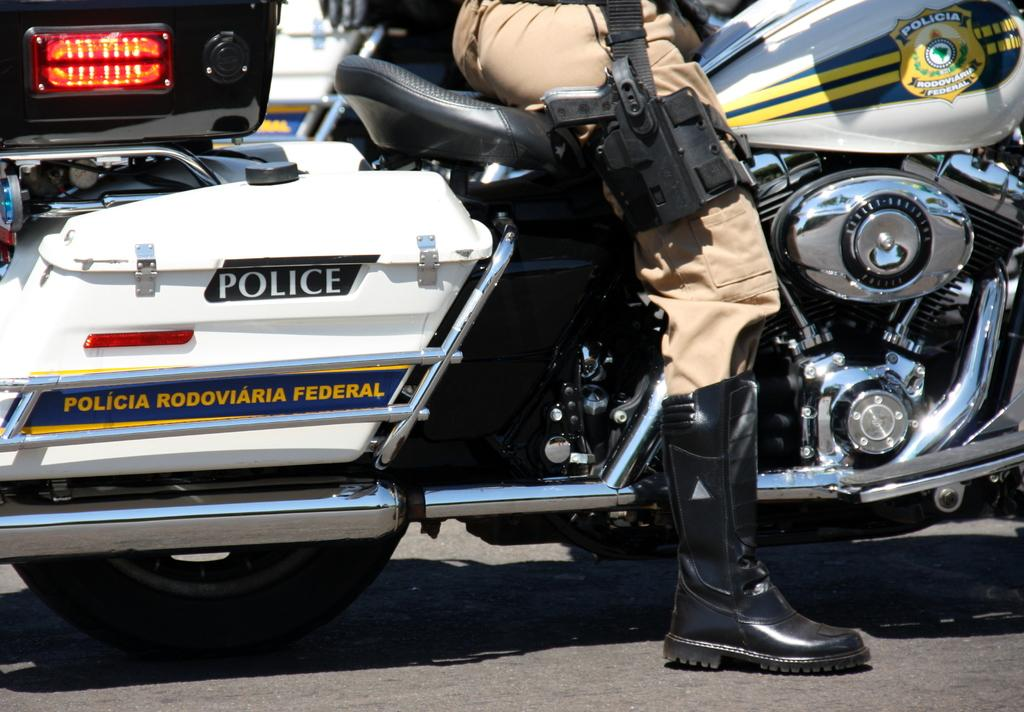What is the main subject of the image? There is a person in the image. What is the person doing in the image? The person is sitting on a bike. What type of stamp can be seen on the person's shirt in the image? There is no stamp visible on the person's shirt in the image. Can you tell me how many ducks are swimming in the background of the image? There are no ducks present in the image; it only features a person sitting on a bike. 